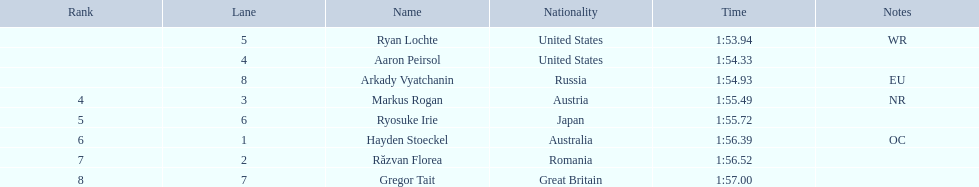Can you name the athletes who took part in the event? Ryan Lochte, Aaron Peirsol, Arkady Vyatchanin, Markus Rogan, Ryosuke Irie, Hayden Stoeckel, Răzvan Florea, Gregor Tait. What was each individual's finishing time? 1:53.94, 1:54.33, 1:54.93, 1:55.49, 1:55.72, 1:56.39, 1:56.52, 1:57.00. Specifically, what was ryosuke irie's time? 1:55.72. 